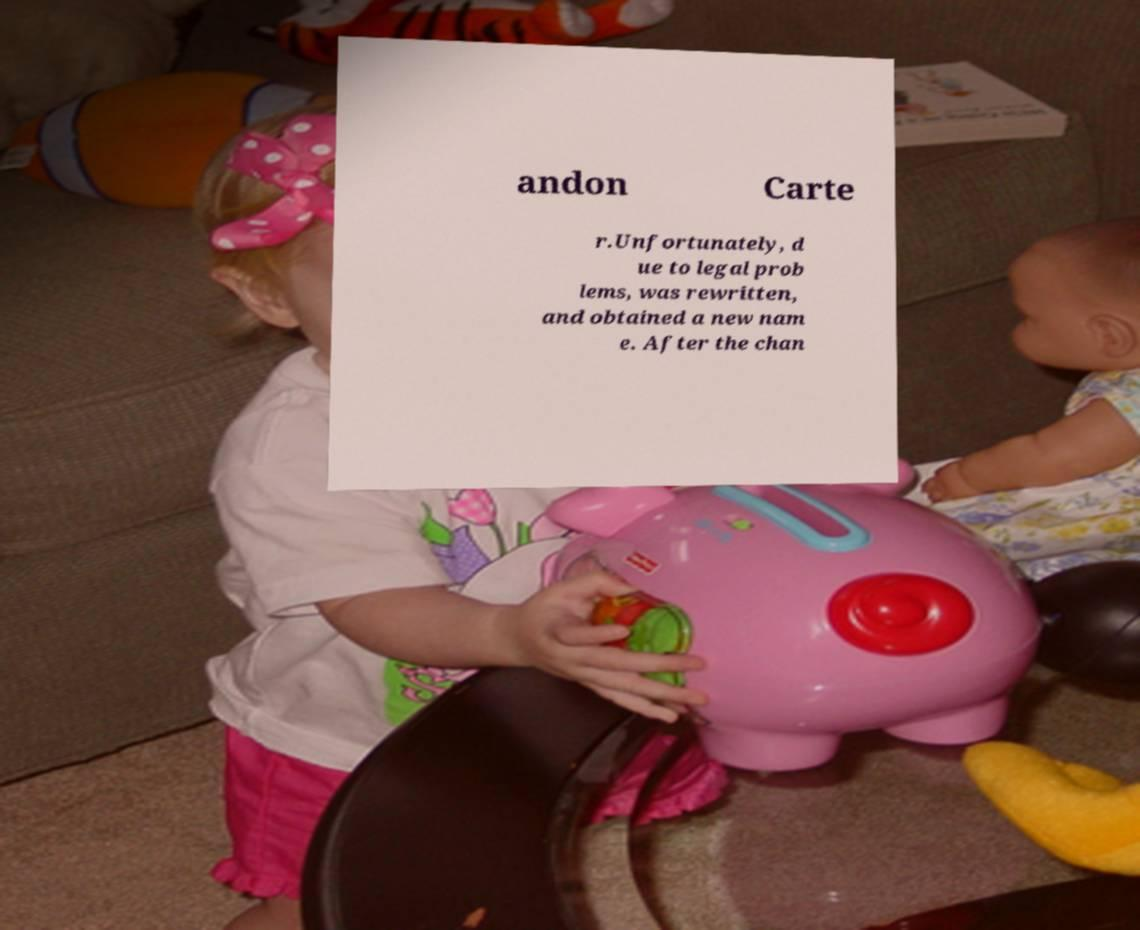There's text embedded in this image that I need extracted. Can you transcribe it verbatim? andon Carte r.Unfortunately, d ue to legal prob lems, was rewritten, and obtained a new nam e. After the chan 